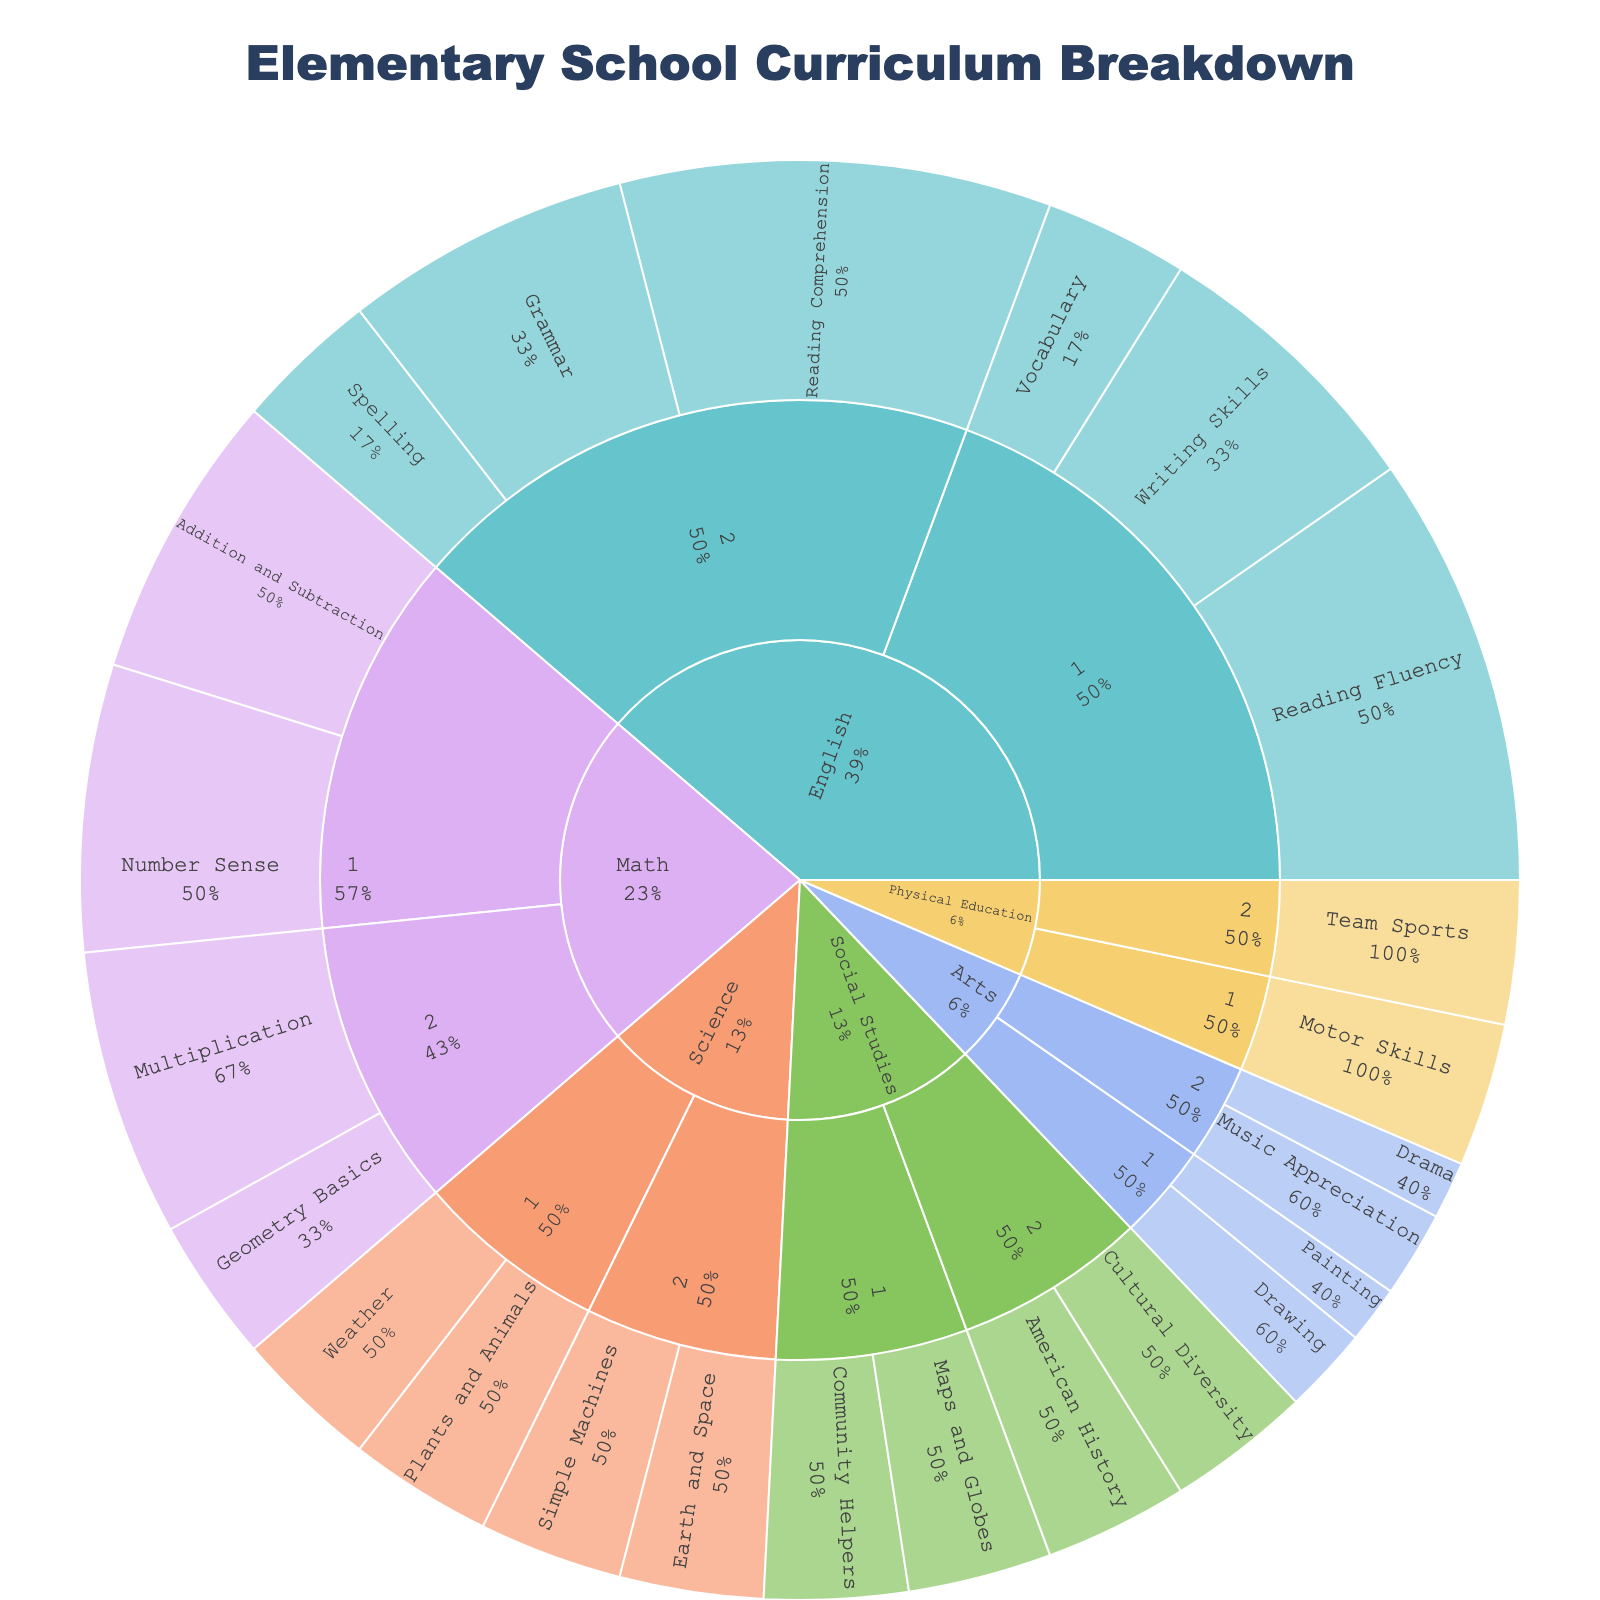What is the title of the sunburst plot? The title of a plot is usually found at the top. In this case, it reads "Elementary School Curriculum Breakdown".
Answer: Elementary School Curriculum Breakdown Which subject in grade 1 has the highest percentage? By observing the segments within the grade 1 category, English has the largest segments for Reading Fluency and Writing Skills. The total percentage for English in grade 1 is 15 (Reading Fluency) + 10 (Writing Skills) + 5 (Vocabulary) = 30.
Answer: English How much percentage is dedicated to Math in grade 2? Checking the percentage segments for Math in grade 2, we see 10 (Multiplication) + 5 (Geometry Basics) = 15.
Answer: 15% What learning outcomes are covered in Physical Education, and what are their percentages? The segments in the plot indicate that in Physical Education, there is Motor Skills in grade 1 and Team Sports in grade 2, both with a percentage of 5.
Answer: Motor Skills (5%), Team Sports (5%) Which grade covers more subjects in the curriculum? Counting the segments within each grade, grade 1 covers English, Math, Science, Social Studies, Arts, and Physical Education, totaling 6 subjects. Grade 2 covers English, Math, Science, Social Studies, Arts, and Physical Education as well, totaling 6 subjects each.
Answer: It's equal, 6 subjects each How do the percentages of learning outcomes in Science compare between grades 1 and 2? In Science grade 1, Plants and Animals and Weather both have 5%, totaling 10%. In Science grade 2, both Earth and Space, and Simple Machines are also 5% each, totaling 10%.
Answer: Both grades have 10% each Which learning outcome in English has the smallest percentage? By observing the English segments, Vocabulary in grade 1 has the smallest percentage, which is 5%.
Answer: Vocabulary (5%) How does the total percentage for Social Studies in grade 1 compare to grade 2? Social Studies in grade 1 has Community Helpers (5%) and Maps and Globes (5%), totaling 10%. In grade 2, it has American History (5%) and Cultural Diversity (5%), also totaling 10%.
Answer: They are equal, both 10% What percentage of the curriculum in grade 2 is dedicated to Arts? Adding up Arts-related segments in grade 2, Music Appreciation has 3% and Drama has 2%, totaling 5%.
Answer: 5% Which grade level has the highest focus on English? Comparing the total percentages dedicated to English: grade 1 has 15 (Reading Fluency) + 10 (Writing Skills) + 5 (Vocabulary) = 30, while grade 2 has 15 (Reading Comprehension) + 10 (Grammar) + 5 (Spelling) = 30. Both grades focus equally on English.
Answer: It's equal for both grades 1 and 2, at 30% each 